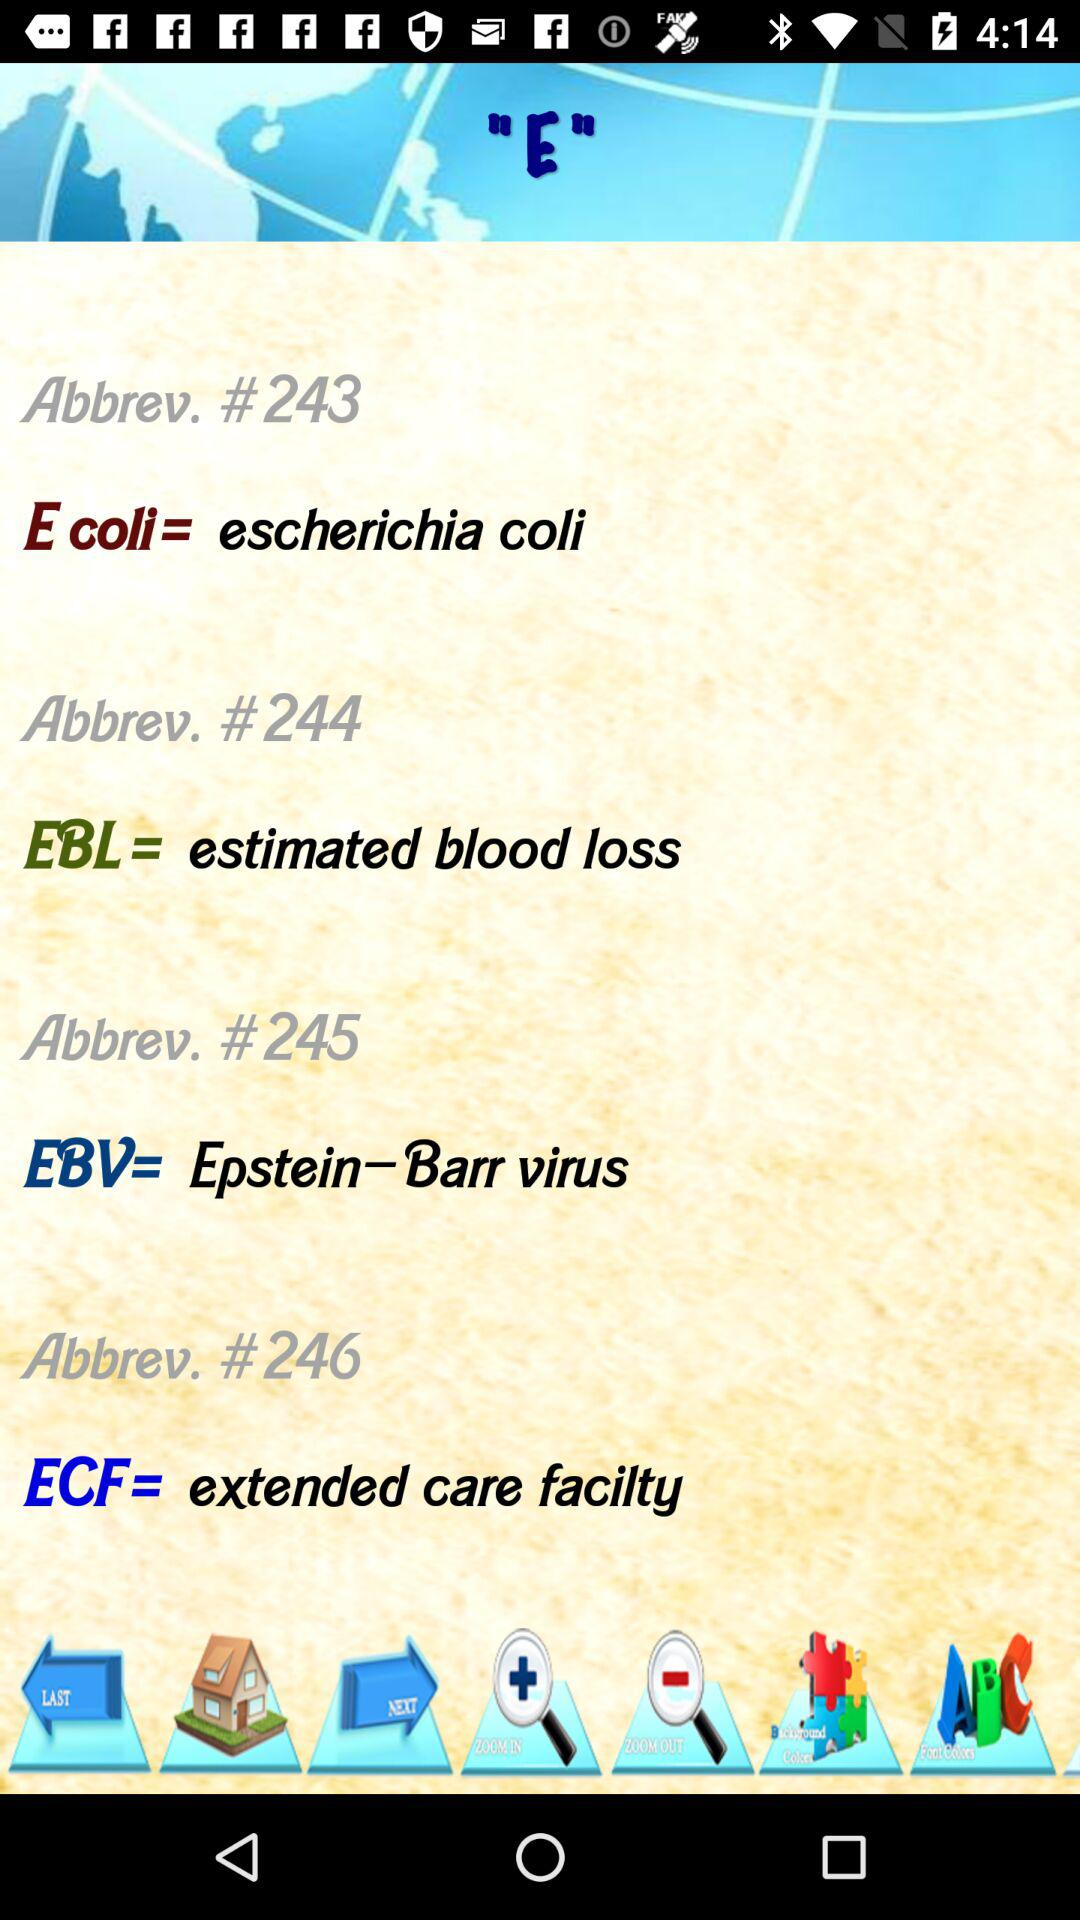What is the full form of EBV?
Answer the question using a single word or phrase. The full form of EBV is Epstein–Barr Virus 